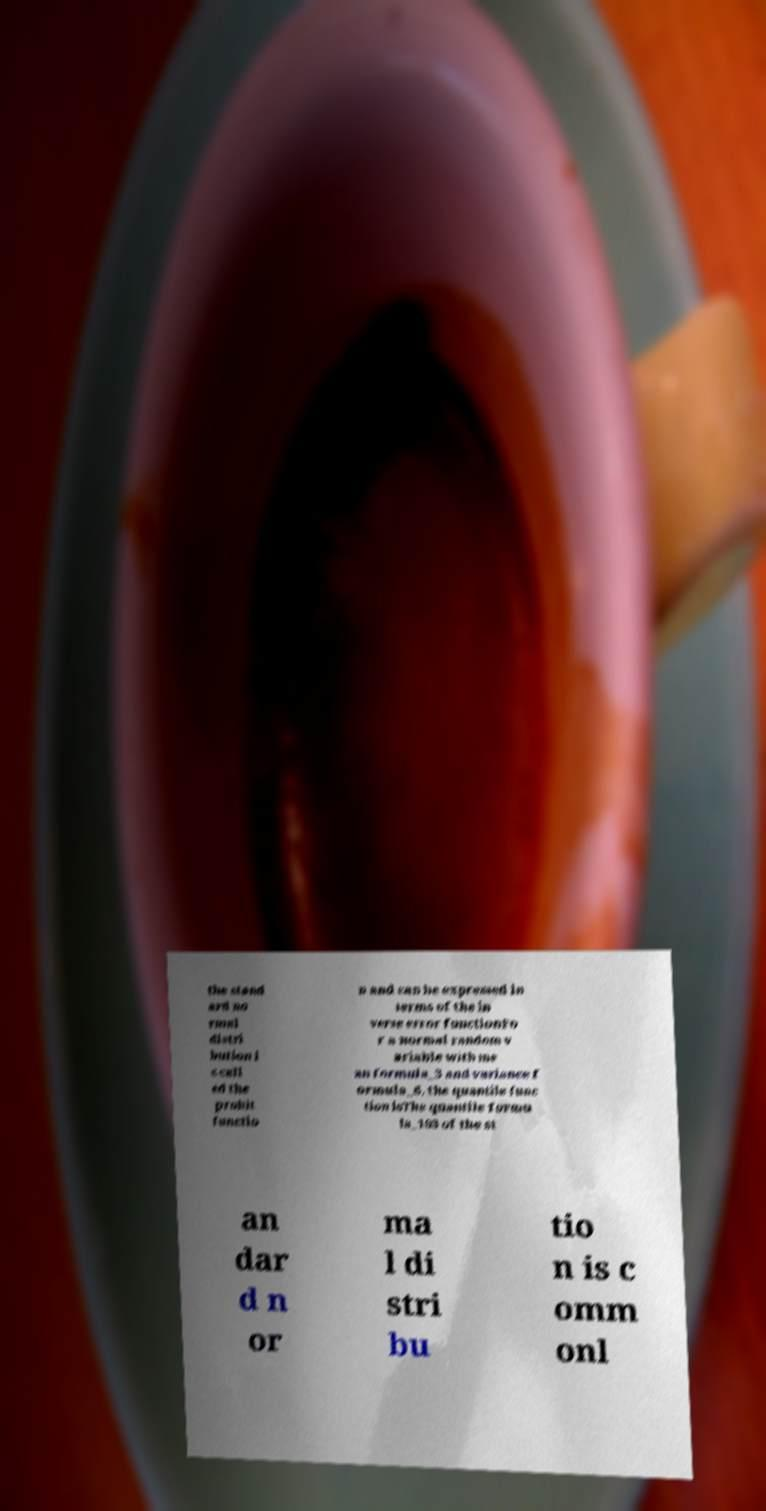Could you assist in decoding the text presented in this image and type it out clearly? the stand ard no rmal distri bution i s call ed the probit functio n and can be expressed in terms of the in verse error functionFo r a normal random v ariable with me an formula_3 and variance f ormula_6, the quantile func tion isThe quantile formu la_103 of the st an dar d n or ma l di stri bu tio n is c omm onl 